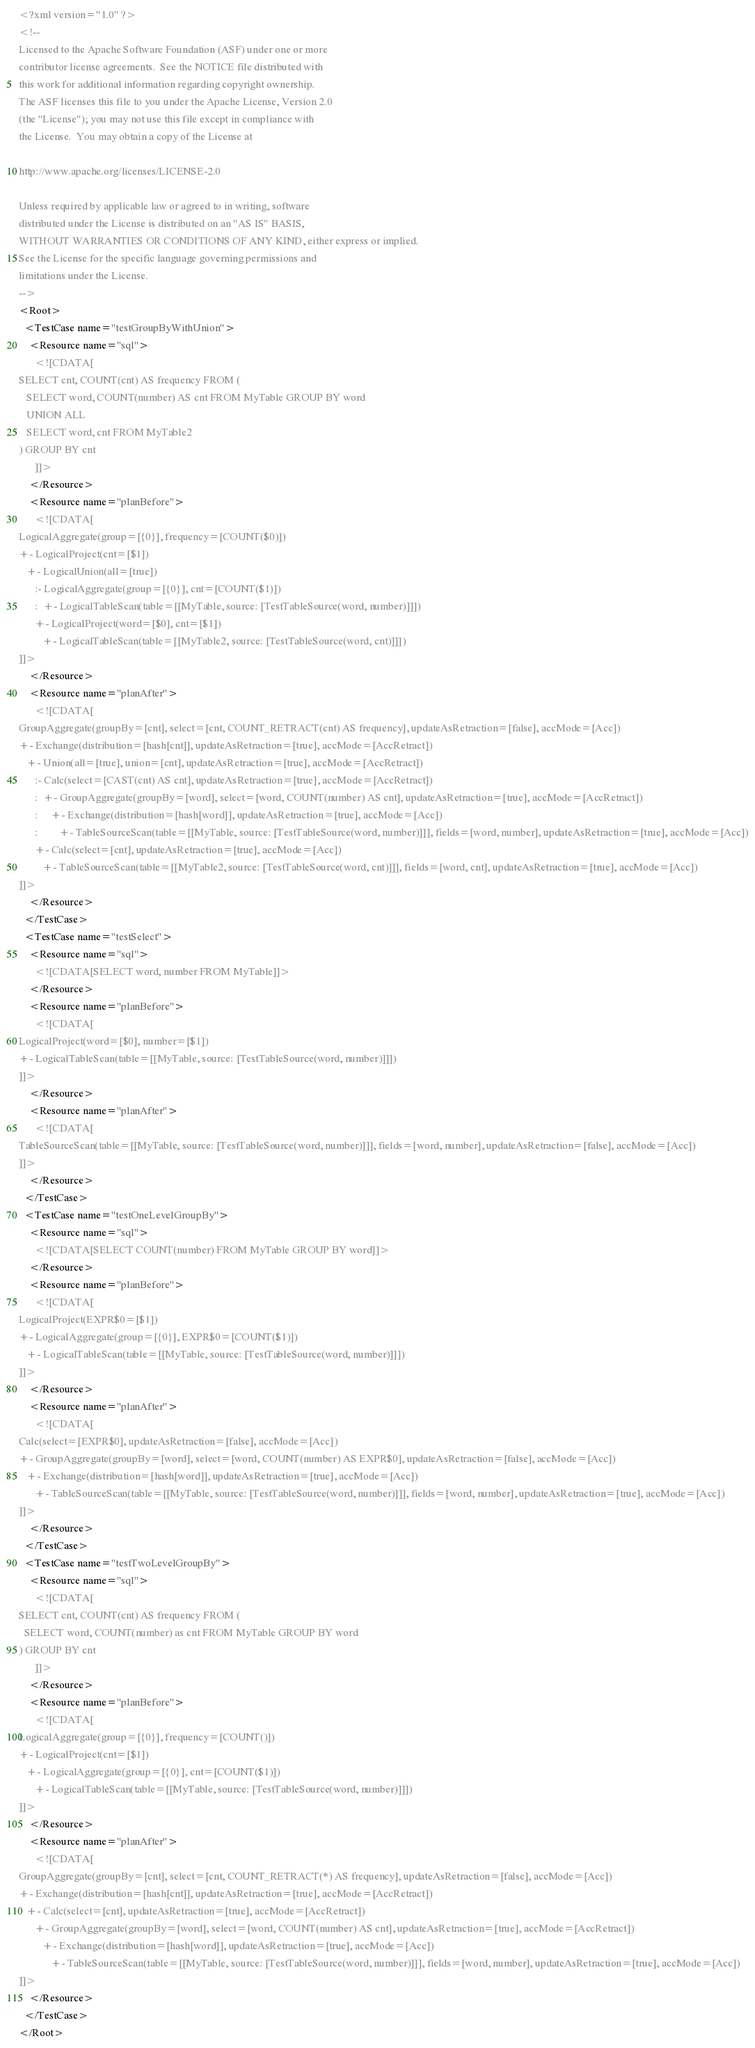<code> <loc_0><loc_0><loc_500><loc_500><_XML_><?xml version="1.0" ?>
<!--
Licensed to the Apache Software Foundation (ASF) under one or more
contributor license agreements.  See the NOTICE file distributed with
this work for additional information regarding copyright ownership.
The ASF licenses this file to you under the Apache License, Version 2.0
(the "License"); you may not use this file except in compliance with
the License.  You may obtain a copy of the License at

http://www.apache.org/licenses/LICENSE-2.0

Unless required by applicable law or agreed to in writing, software
distributed under the License is distributed on an "AS IS" BASIS,
WITHOUT WARRANTIES OR CONDITIONS OF ANY KIND, either express or implied.
See the License for the specific language governing permissions and
limitations under the License.
-->
<Root>
  <TestCase name="testGroupByWithUnion">
    <Resource name="sql">
      <![CDATA[
SELECT cnt, COUNT(cnt) AS frequency FROM (
   SELECT word, COUNT(number) AS cnt FROM MyTable GROUP BY word
   UNION ALL
   SELECT word, cnt FROM MyTable2
) GROUP BY cnt
      ]]>
    </Resource>
    <Resource name="planBefore">
      <![CDATA[
LogicalAggregate(group=[{0}], frequency=[COUNT($0)])
+- LogicalProject(cnt=[$1])
   +- LogicalUnion(all=[true])
      :- LogicalAggregate(group=[{0}], cnt=[COUNT($1)])
      :  +- LogicalTableScan(table=[[MyTable, source: [TestTableSource(word, number)]]])
      +- LogicalProject(word=[$0], cnt=[$1])
         +- LogicalTableScan(table=[[MyTable2, source: [TestTableSource(word, cnt)]]])
]]>
    </Resource>
    <Resource name="planAfter">
      <![CDATA[
GroupAggregate(groupBy=[cnt], select=[cnt, COUNT_RETRACT(cnt) AS frequency], updateAsRetraction=[false], accMode=[Acc])
+- Exchange(distribution=[hash[cnt]], updateAsRetraction=[true], accMode=[AccRetract])
   +- Union(all=[true], union=[cnt], updateAsRetraction=[true], accMode=[AccRetract])
      :- Calc(select=[CAST(cnt) AS cnt], updateAsRetraction=[true], accMode=[AccRetract])
      :  +- GroupAggregate(groupBy=[word], select=[word, COUNT(number) AS cnt], updateAsRetraction=[true], accMode=[AccRetract])
      :     +- Exchange(distribution=[hash[word]], updateAsRetraction=[true], accMode=[Acc])
      :        +- TableSourceScan(table=[[MyTable, source: [TestTableSource(word, number)]]], fields=[word, number], updateAsRetraction=[true], accMode=[Acc])
      +- Calc(select=[cnt], updateAsRetraction=[true], accMode=[Acc])
         +- TableSourceScan(table=[[MyTable2, source: [TestTableSource(word, cnt)]]], fields=[word, cnt], updateAsRetraction=[true], accMode=[Acc])
]]>
    </Resource>
  </TestCase>
  <TestCase name="testSelect">
    <Resource name="sql">
      <![CDATA[SELECT word, number FROM MyTable]]>
    </Resource>
    <Resource name="planBefore">
      <![CDATA[
LogicalProject(word=[$0], number=[$1])
+- LogicalTableScan(table=[[MyTable, source: [TestTableSource(word, number)]]])
]]>
    </Resource>
    <Resource name="planAfter">
      <![CDATA[
TableSourceScan(table=[[MyTable, source: [TestTableSource(word, number)]]], fields=[word, number], updateAsRetraction=[false], accMode=[Acc])
]]>
    </Resource>
  </TestCase>
  <TestCase name="testOneLevelGroupBy">
    <Resource name="sql">
      <![CDATA[SELECT COUNT(number) FROM MyTable GROUP BY word]]>
    </Resource>
    <Resource name="planBefore">
      <![CDATA[
LogicalProject(EXPR$0=[$1])
+- LogicalAggregate(group=[{0}], EXPR$0=[COUNT($1)])
   +- LogicalTableScan(table=[[MyTable, source: [TestTableSource(word, number)]]])
]]>
    </Resource>
    <Resource name="planAfter">
      <![CDATA[
Calc(select=[EXPR$0], updateAsRetraction=[false], accMode=[Acc])
+- GroupAggregate(groupBy=[word], select=[word, COUNT(number) AS EXPR$0], updateAsRetraction=[false], accMode=[Acc])
   +- Exchange(distribution=[hash[word]], updateAsRetraction=[true], accMode=[Acc])
      +- TableSourceScan(table=[[MyTable, source: [TestTableSource(word, number)]]], fields=[word, number], updateAsRetraction=[true], accMode=[Acc])
]]>
    </Resource>
  </TestCase>
  <TestCase name="testTwoLevelGroupBy">
    <Resource name="sql">
      <![CDATA[
SELECT cnt, COUNT(cnt) AS frequency FROM (
  SELECT word, COUNT(number) as cnt FROM MyTable GROUP BY word
) GROUP BY cnt
      ]]>
    </Resource>
    <Resource name="planBefore">
      <![CDATA[
LogicalAggregate(group=[{0}], frequency=[COUNT()])
+- LogicalProject(cnt=[$1])
   +- LogicalAggregate(group=[{0}], cnt=[COUNT($1)])
      +- LogicalTableScan(table=[[MyTable, source: [TestTableSource(word, number)]]])
]]>
    </Resource>
    <Resource name="planAfter">
      <![CDATA[
GroupAggregate(groupBy=[cnt], select=[cnt, COUNT_RETRACT(*) AS frequency], updateAsRetraction=[false], accMode=[Acc])
+- Exchange(distribution=[hash[cnt]], updateAsRetraction=[true], accMode=[AccRetract])
   +- Calc(select=[cnt], updateAsRetraction=[true], accMode=[AccRetract])
      +- GroupAggregate(groupBy=[word], select=[word, COUNT(number) AS cnt], updateAsRetraction=[true], accMode=[AccRetract])
         +- Exchange(distribution=[hash[word]], updateAsRetraction=[true], accMode=[Acc])
            +- TableSourceScan(table=[[MyTable, source: [TestTableSource(word, number)]]], fields=[word, number], updateAsRetraction=[true], accMode=[Acc])
]]>
    </Resource>
  </TestCase>
</Root>
</code> 